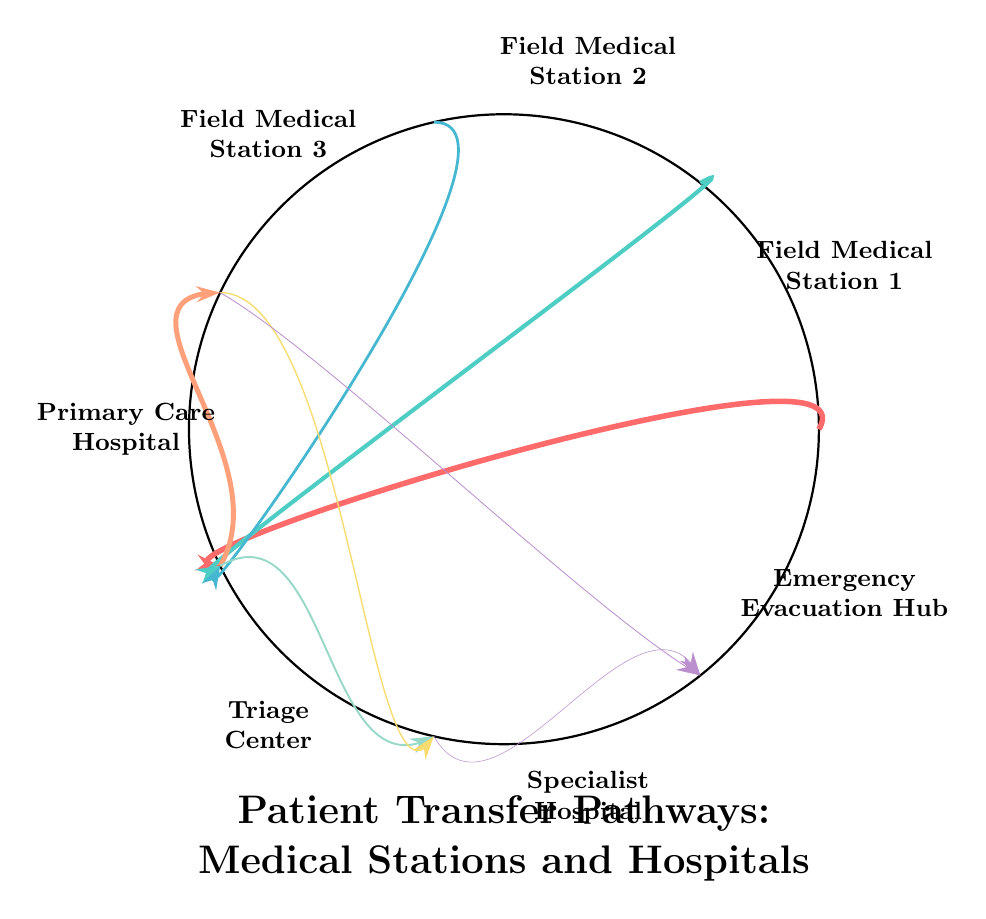What's the total number of nodes in the diagram? The diagram contains 7 nodes: Field Medical Station 1, Field Medical Station 2, Field Medical Station 3, Primary Care Hospital, Triage Center, Specialist Hospital, and Emergency Evacuation Hub.
Answer: 7 Which node has the highest patient transfer value to Triage Center? The highest patient transfer value to the Triage Center comes from Field Medical Station 1, with a value of 20.
Answer: Field Medical Station 1 How many patients are transferred from Field Medical Station 3 to Triage Center? The value representing patient transfers from Field Medical Station 3 to the Triage Center is 10, which indicates the number of patients transferred.
Answer: 10 What is the total number of patients transferred to the Primary Care Hospital from the Triage Center? The only pathway leading to the Primary Care Hospital from the Triage Center has a patient transfer value of 18, meaning 18 patients are transferred to it.
Answer: 18 Comparing values, which hospital receives more patient transfers, Specialist Hospital or Emergency Evacuation Hub? The Specialist Hospital receives 7 patients from the Triage Center and 5 patients from the Primary Care Hospital, totaling 12, whereas the Emergency Evacuation Hub receives 3 patients from the Primary Care Hospital and 2 from the Specialist Hospital, totaling 5. Therefore, the Specialist Hospital receives more patient transfers.
Answer: Specialist Hospital From which node is the second highest number of patients transferred to Triage Center, and how many? The second highest number of patients transferred to the Triage Center is from Field Medical Station 2, with a value of 15.
Answer: Field Medical Station 2, 15 Which pathway has the least patient transfers shown in the diagram? The pathway from Specialist Hospital to Emergency Evacuation Hub has the least patient transfers, with a value of 2.
Answer: Specialist Hospital to Emergency Evacuation Hub, 2 Which two nodes are directly linked to Emergency Evacuation Hub? The Emergency Evacuation Hub is directly linked to Primary Care Hospital and Specialist Hospital.
Answer: Primary Care Hospital and Specialist Hospital How many total patients are being transferred from Triage Center to hospitals? The total patients transferred from the Triage Center are to the Primary Care Hospital (18) and the Specialist Hospital (7), summing up to 25 patients.
Answer: 25 